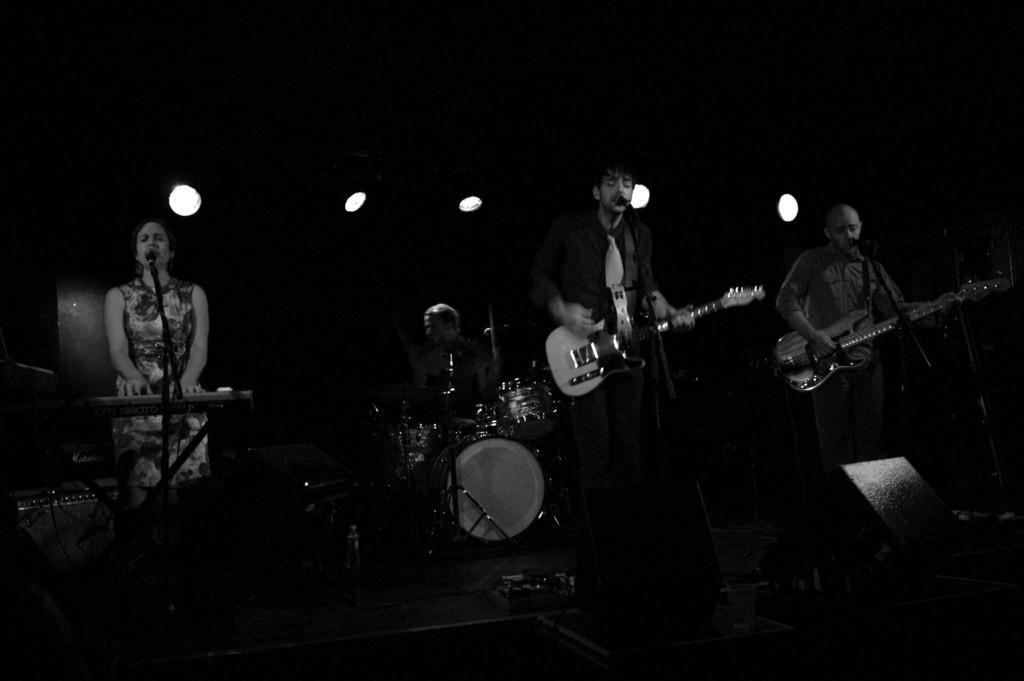Describe this image in one or two sentences. In this Picture we can see the a group of three man and one woman are playing musical show on the stage, On the left we can see man singing in the microphone and playing guitar, Center a man wearing black shirt and white tie is also singing and playing the guitar , Beside a man wearing colorful dress is singing and playing piano. Behind we can see the man sitting and playing the band. On the ground we see three big speakers , cables and some spotlight on the top. 